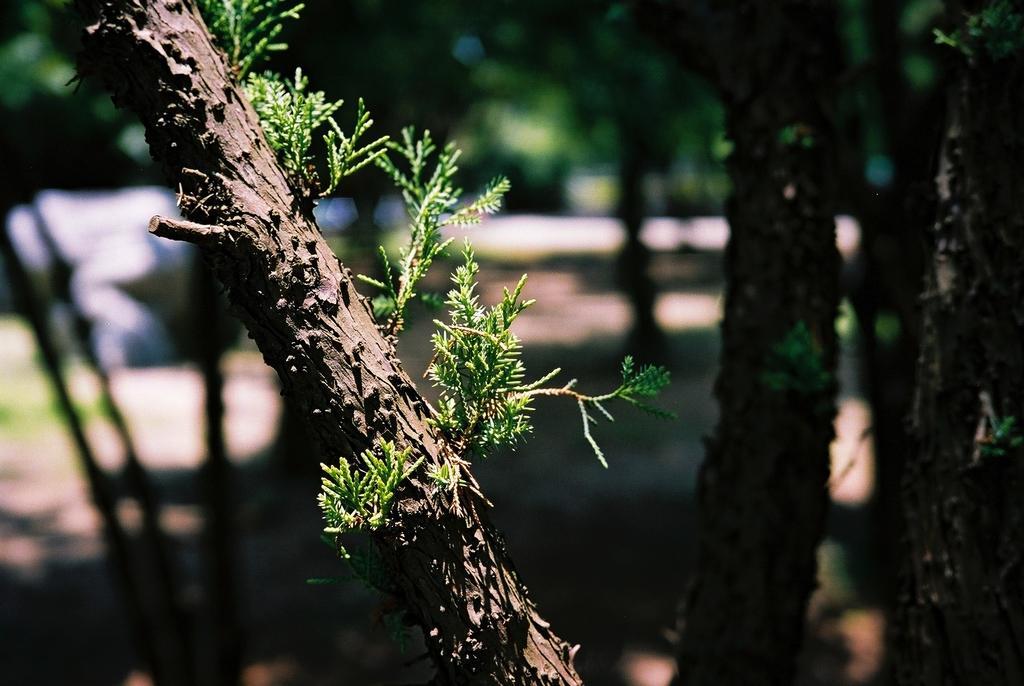Can you describe this image briefly? In this I can see the leaves to a stem. On the right side there are few tree trunks. The background is blurred. 